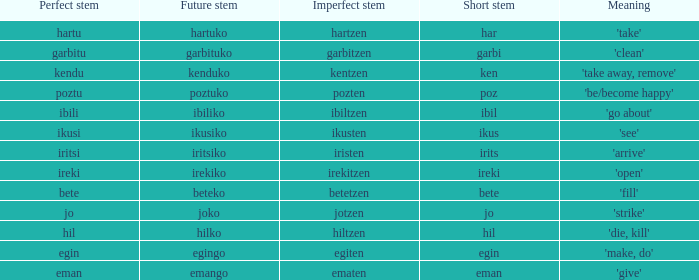Identify the ideal stem for jo. 1.0. Write the full table. {'header': ['Perfect stem', 'Future stem', 'Imperfect stem', 'Short stem', 'Meaning'], 'rows': [['hartu', 'hartuko', 'hartzen', 'har', "'take'"], ['garbitu', 'garbituko', 'garbitzen', 'garbi', "'clean'"], ['kendu', 'kenduko', 'kentzen', 'ken', "'take away, remove'"], ['poztu', 'poztuko', 'pozten', 'poz', "'be/become happy'"], ['ibili', 'ibiliko', 'ibiltzen', 'ibil', "'go about'"], ['ikusi', 'ikusiko', 'ikusten', 'ikus', "'see'"], ['iritsi', 'iritsiko', 'iristen', 'irits', "'arrive'"], ['ireki', 'irekiko', 'irekitzen', 'ireki', "'open'"], ['bete', 'beteko', 'betetzen', 'bete', "'fill'"], ['jo', 'joko', 'jotzen', 'jo', "'strike'"], ['hil', 'hilko', 'hiltzen', 'hil', "'die, kill'"], ['egin', 'egingo', 'egiten', 'egin', "'make, do'"], ['eman', 'emango', 'ematen', 'eman', "'give'"]]} 